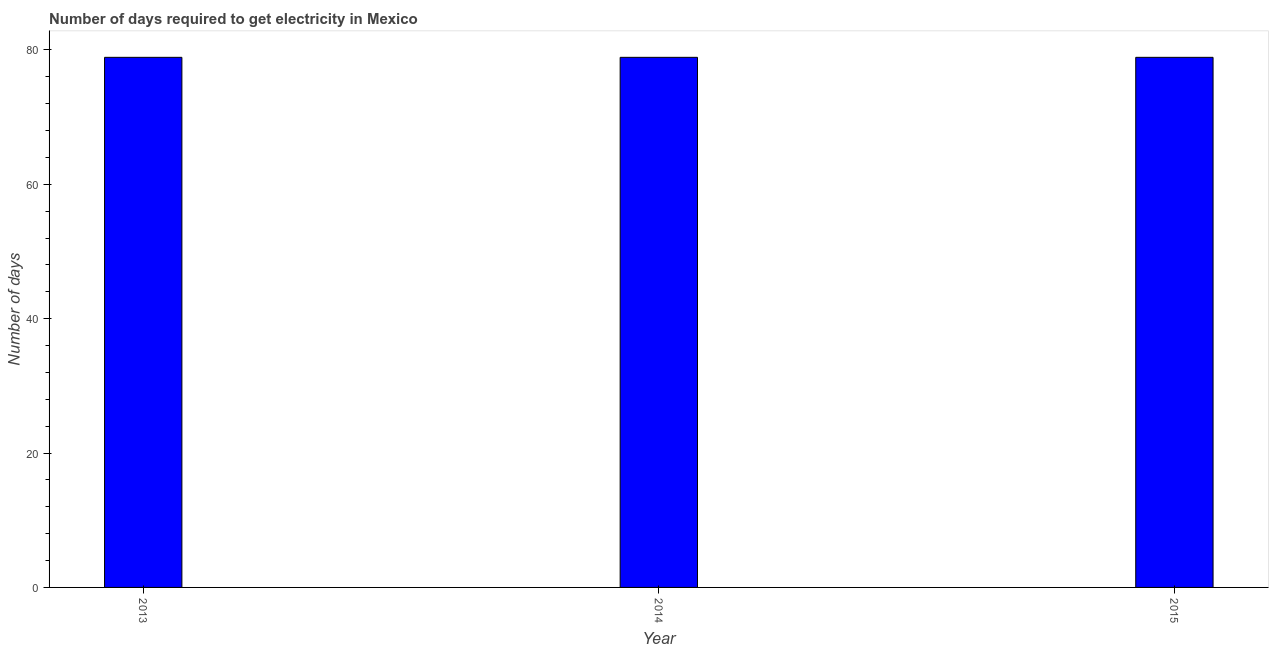Does the graph contain any zero values?
Your answer should be very brief. No. What is the title of the graph?
Your answer should be compact. Number of days required to get electricity in Mexico. What is the label or title of the Y-axis?
Provide a short and direct response. Number of days. What is the time to get electricity in 2015?
Your answer should be compact. 78.9. Across all years, what is the maximum time to get electricity?
Provide a short and direct response. 78.9. Across all years, what is the minimum time to get electricity?
Offer a very short reply. 78.9. In which year was the time to get electricity maximum?
Your answer should be compact. 2013. In which year was the time to get electricity minimum?
Keep it short and to the point. 2013. What is the sum of the time to get electricity?
Provide a short and direct response. 236.7. What is the difference between the time to get electricity in 2013 and 2014?
Give a very brief answer. 0. What is the average time to get electricity per year?
Offer a very short reply. 78.9. What is the median time to get electricity?
Offer a very short reply. 78.9. What is the ratio of the time to get electricity in 2014 to that in 2015?
Ensure brevity in your answer.  1. Is the difference between the time to get electricity in 2013 and 2015 greater than the difference between any two years?
Offer a very short reply. Yes. What is the difference between the highest and the second highest time to get electricity?
Your response must be concise. 0. Is the sum of the time to get electricity in 2014 and 2015 greater than the maximum time to get electricity across all years?
Keep it short and to the point. Yes. Are all the bars in the graph horizontal?
Your response must be concise. No. What is the Number of days of 2013?
Keep it short and to the point. 78.9. What is the Number of days of 2014?
Make the answer very short. 78.9. What is the Number of days of 2015?
Offer a very short reply. 78.9. What is the ratio of the Number of days in 2013 to that in 2014?
Your answer should be compact. 1. 